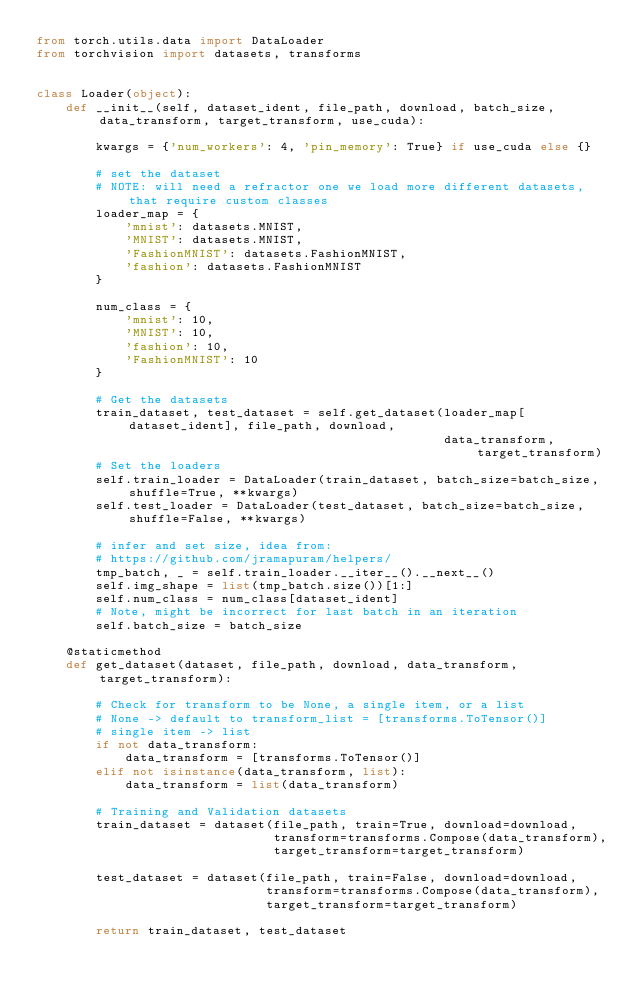Convert code to text. <code><loc_0><loc_0><loc_500><loc_500><_Python_>from torch.utils.data import DataLoader
from torchvision import datasets, transforms


class Loader(object):
    def __init__(self, dataset_ident, file_path, download, batch_size, data_transform, target_transform, use_cuda):

        kwargs = {'num_workers': 4, 'pin_memory': True} if use_cuda else {}

        # set the dataset
        # NOTE: will need a refractor one we load more different datasets, that require custom classes
        loader_map = {
            'mnist': datasets.MNIST,
            'MNIST': datasets.MNIST,
            'FashionMNIST': datasets.FashionMNIST,
            'fashion': datasets.FashionMNIST
        }

        num_class = {
            'mnist': 10,
            'MNIST': 10,
            'fashion': 10,
            'FashionMNIST': 10
        }

        # Get the datasets
        train_dataset, test_dataset = self.get_dataset(loader_map[dataset_ident], file_path, download,
                                                       data_transform, target_transform)
        # Set the loaders
        self.train_loader = DataLoader(train_dataset, batch_size=batch_size, shuffle=True, **kwargs)
        self.test_loader = DataLoader(test_dataset, batch_size=batch_size, shuffle=False, **kwargs)

        # infer and set size, idea from:
        # https://github.com/jramapuram/helpers/
        tmp_batch, _ = self.train_loader.__iter__().__next__()
        self.img_shape = list(tmp_batch.size())[1:]
        self.num_class = num_class[dataset_ident]
        # Note, might be incorrect for last batch in an iteration
        self.batch_size = batch_size

    @staticmethod
    def get_dataset(dataset, file_path, download, data_transform, target_transform):

        # Check for transform to be None, a single item, or a list
        # None -> default to transform_list = [transforms.ToTensor()]
        # single item -> list
        if not data_transform:
            data_transform = [transforms.ToTensor()]
        elif not isinstance(data_transform, list):
            data_transform = list(data_transform)

        # Training and Validation datasets
        train_dataset = dataset(file_path, train=True, download=download,
                                transform=transforms.Compose(data_transform),
                                target_transform=target_transform)

        test_dataset = dataset(file_path, train=False, download=download,
                               transform=transforms.Compose(data_transform),
                               target_transform=target_transform)

        return train_dataset, test_dataset
</code> 